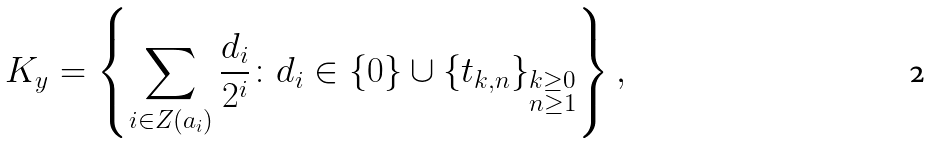Convert formula to latex. <formula><loc_0><loc_0><loc_500><loc_500>K _ { y } = \left \{ \sum _ { i \in Z ( a _ { i } ) } \frac { d _ { i } } { 2 ^ { i } } \colon d _ { i } \in \{ 0 \} \cup \{ t _ { k , n } \} _ { \substack { k \geq 0 \\ n \geq 1 } } \right \} ,</formula> 